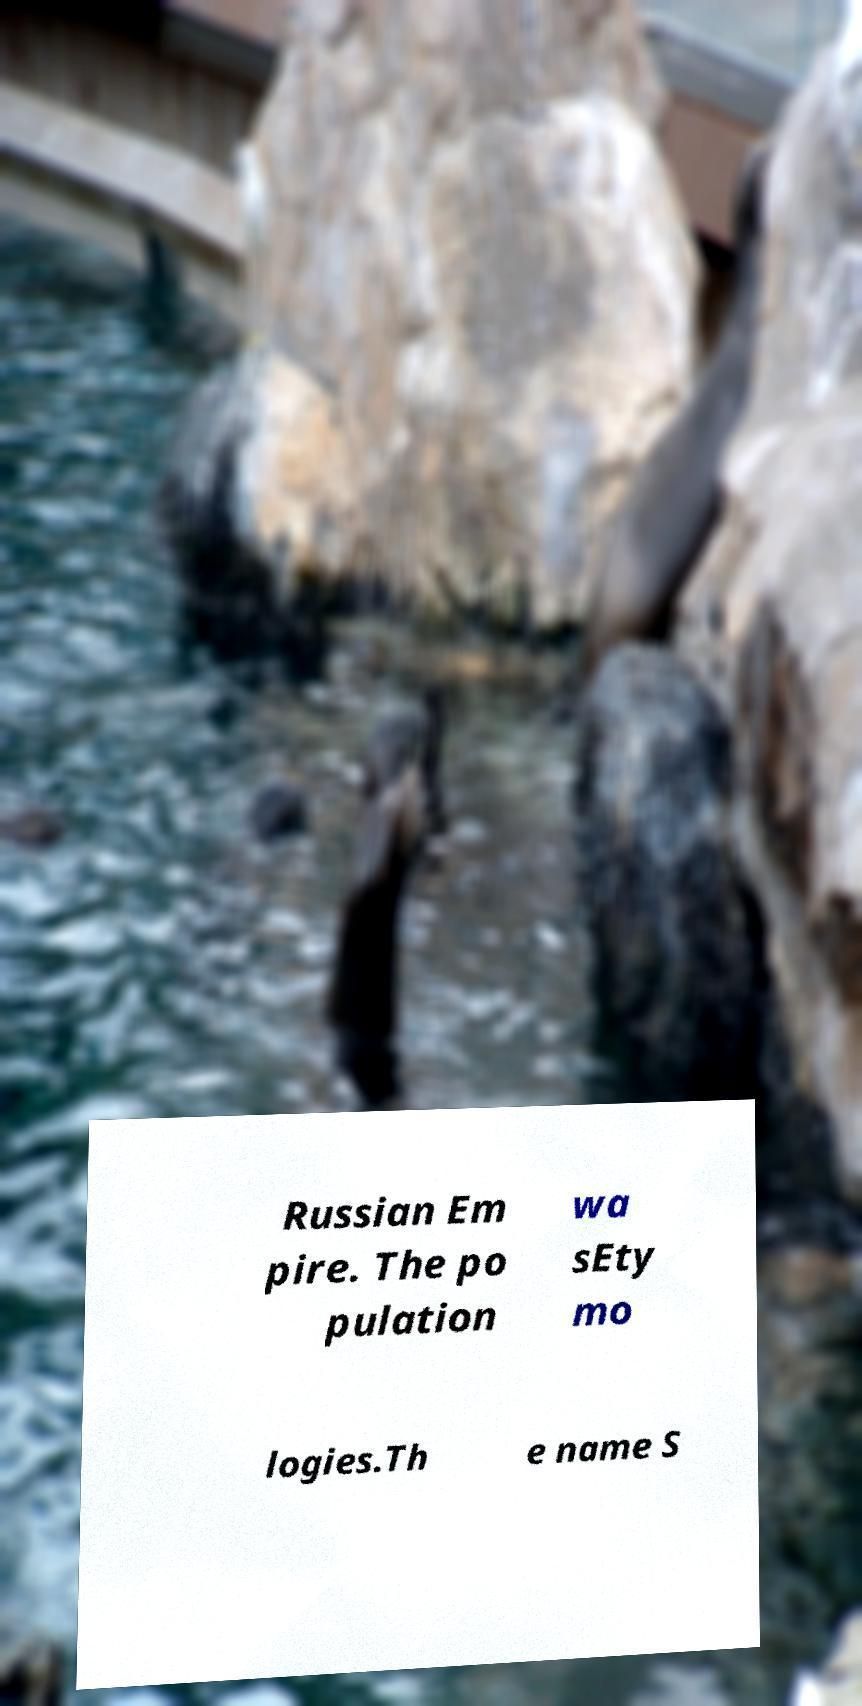Could you assist in decoding the text presented in this image and type it out clearly? Russian Em pire. The po pulation wa sEty mo logies.Th e name S 